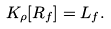Convert formula to latex. <formula><loc_0><loc_0><loc_500><loc_500>K _ { \rho } [ R _ { f } ] = L _ { f } .</formula> 